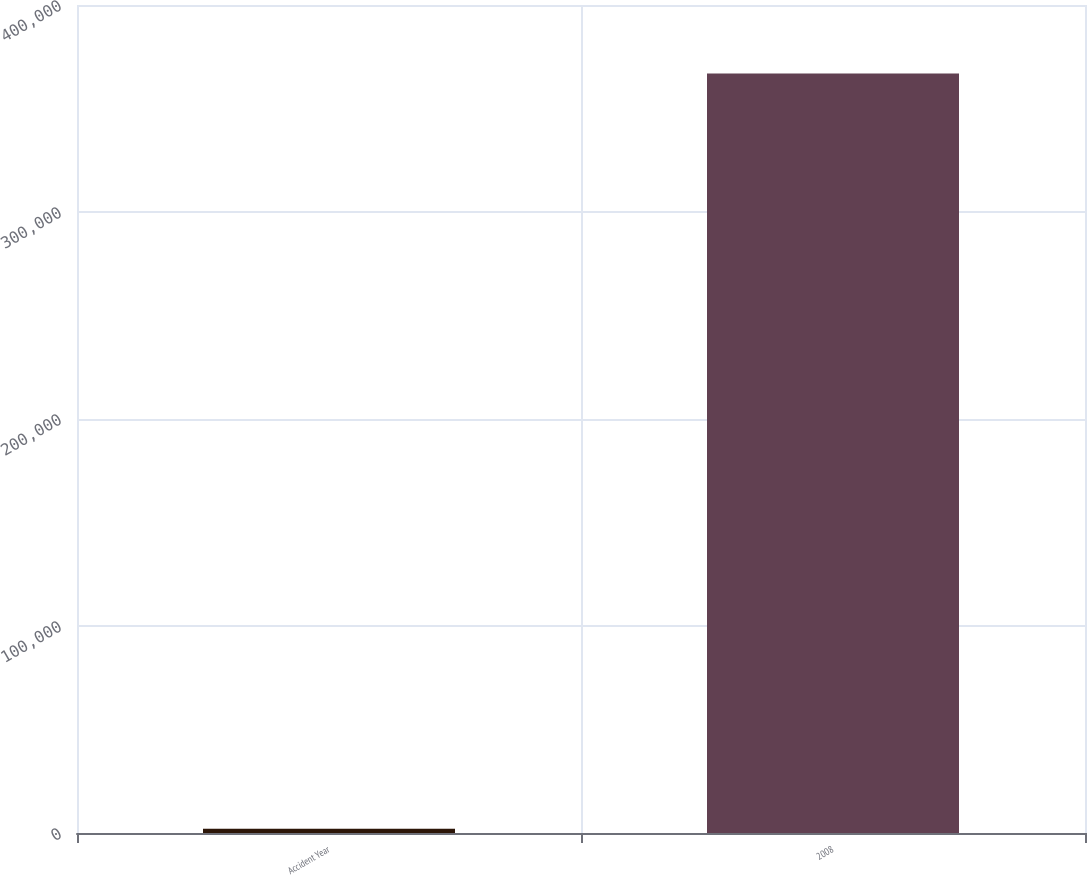Convert chart to OTSL. <chart><loc_0><loc_0><loc_500><loc_500><bar_chart><fcel>Accident Year<fcel>2008<nl><fcel>2016<fcel>366953<nl></chart> 